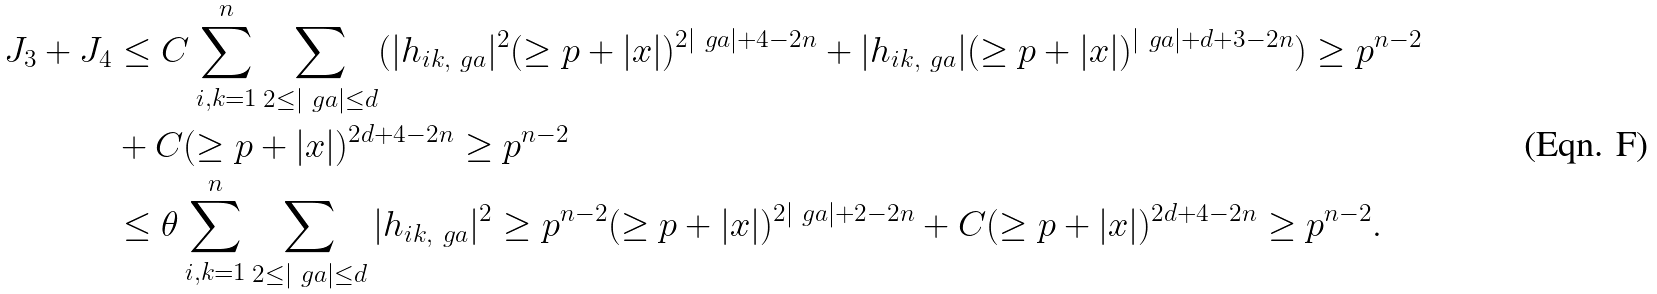Convert formula to latex. <formula><loc_0><loc_0><loc_500><loc_500>J _ { 3 } + J _ { 4 } & \leq C \sum _ { i , k = 1 } ^ { n } \sum _ { 2 \leq | \ g a | \leq d } ( | h _ { i k , \ g a } | ^ { 2 } ( \geq p + | x | ) ^ { 2 | \ g a | + 4 - 2 n } + | h _ { i k , \ g a } | ( \geq p + | x | ) ^ { | \ g a | + d + 3 - 2 n } ) \geq p ^ { n - 2 } \\ & + C ( \geq p + | x | ) ^ { 2 d + 4 - 2 n } \geq p ^ { n - 2 } \\ & \leq \theta \sum _ { i , k = 1 } ^ { n } \sum _ { 2 \leq | \ g a | \leq d } | h _ { i k , \ g a } | ^ { 2 } \geq p ^ { n - 2 } ( \geq p + | x | ) ^ { 2 | \ g a | + 2 - 2 n } + C ( \geq p + | x | ) ^ { 2 d + 4 - 2 n } \geq p ^ { n - 2 } .</formula> 